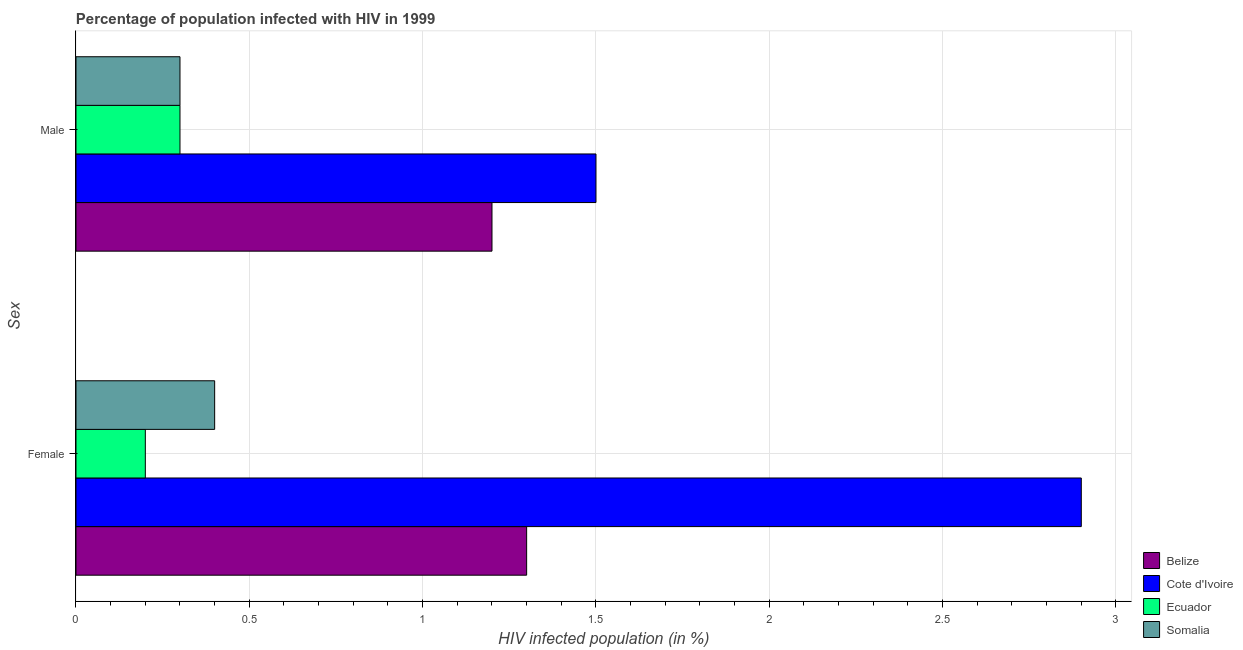How many different coloured bars are there?
Offer a very short reply. 4. How many groups of bars are there?
Your answer should be compact. 2. Are the number of bars per tick equal to the number of legend labels?
Your answer should be compact. Yes. Are the number of bars on each tick of the Y-axis equal?
Your answer should be very brief. Yes. How many bars are there on the 2nd tick from the bottom?
Make the answer very short. 4. Across all countries, what is the maximum percentage of males who are infected with hiv?
Provide a short and direct response. 1.5. Across all countries, what is the minimum percentage of males who are infected with hiv?
Provide a short and direct response. 0.3. In which country was the percentage of males who are infected with hiv maximum?
Make the answer very short. Cote d'Ivoire. In which country was the percentage of females who are infected with hiv minimum?
Your answer should be compact. Ecuador. What is the total percentage of females who are infected with hiv in the graph?
Your answer should be compact. 4.8. What is the difference between the percentage of males who are infected with hiv in Cote d'Ivoire and that in Belize?
Offer a very short reply. 0.3. What is the difference between the percentage of females who are infected with hiv in Belize and the percentage of males who are infected with hiv in Cote d'Ivoire?
Ensure brevity in your answer.  -0.2. What is the average percentage of females who are infected with hiv per country?
Your answer should be compact. 1.2. What is the difference between the percentage of females who are infected with hiv and percentage of males who are infected with hiv in Belize?
Provide a succinct answer. 0.1. In how many countries, is the percentage of females who are infected with hiv greater than 1 %?
Offer a terse response. 2. What is the ratio of the percentage of males who are infected with hiv in Belize to that in Cote d'Ivoire?
Provide a succinct answer. 0.8. Is the percentage of males who are infected with hiv in Belize less than that in Somalia?
Offer a very short reply. No. What does the 3rd bar from the top in Male represents?
Provide a succinct answer. Cote d'Ivoire. What does the 1st bar from the bottom in Female represents?
Your answer should be very brief. Belize. How many bars are there?
Keep it short and to the point. 8. Are all the bars in the graph horizontal?
Your answer should be compact. Yes. What is the difference between two consecutive major ticks on the X-axis?
Provide a succinct answer. 0.5. Does the graph contain any zero values?
Provide a short and direct response. No. Does the graph contain grids?
Provide a short and direct response. Yes. How many legend labels are there?
Offer a very short reply. 4. What is the title of the graph?
Your answer should be very brief. Percentage of population infected with HIV in 1999. What is the label or title of the X-axis?
Make the answer very short. HIV infected population (in %). What is the label or title of the Y-axis?
Your answer should be compact. Sex. What is the HIV infected population (in %) in Belize in Female?
Ensure brevity in your answer.  1.3. What is the HIV infected population (in %) of Cote d'Ivoire in Female?
Offer a very short reply. 2.9. What is the HIV infected population (in %) in Somalia in Female?
Ensure brevity in your answer.  0.4. What is the HIV infected population (in %) of Cote d'Ivoire in Male?
Offer a very short reply. 1.5. What is the HIV infected population (in %) of Somalia in Male?
Your answer should be very brief. 0.3. Across all Sex, what is the maximum HIV infected population (in %) in Belize?
Offer a terse response. 1.3. Across all Sex, what is the maximum HIV infected population (in %) of Cote d'Ivoire?
Provide a succinct answer. 2.9. Across all Sex, what is the minimum HIV infected population (in %) of Ecuador?
Keep it short and to the point. 0.2. What is the total HIV infected population (in %) in Belize in the graph?
Make the answer very short. 2.5. What is the total HIV infected population (in %) of Cote d'Ivoire in the graph?
Make the answer very short. 4.4. What is the total HIV infected population (in %) of Ecuador in the graph?
Your answer should be compact. 0.5. What is the total HIV infected population (in %) in Somalia in the graph?
Your answer should be very brief. 0.7. What is the difference between the HIV infected population (in %) of Belize in Female and that in Male?
Make the answer very short. 0.1. What is the difference between the HIV infected population (in %) of Cote d'Ivoire in Female and that in Male?
Your answer should be very brief. 1.4. What is the difference between the HIV infected population (in %) in Ecuador in Female and that in Male?
Your answer should be compact. -0.1. What is the difference between the HIV infected population (in %) of Somalia in Female and that in Male?
Your response must be concise. 0.1. What is the average HIV infected population (in %) of Belize per Sex?
Your response must be concise. 1.25. What is the average HIV infected population (in %) in Cote d'Ivoire per Sex?
Make the answer very short. 2.2. What is the average HIV infected population (in %) of Ecuador per Sex?
Ensure brevity in your answer.  0.25. What is the difference between the HIV infected population (in %) of Belize and HIV infected population (in %) of Cote d'Ivoire in Female?
Ensure brevity in your answer.  -1.6. What is the difference between the HIV infected population (in %) of Belize and HIV infected population (in %) of Somalia in Female?
Offer a very short reply. 0.9. What is the difference between the HIV infected population (in %) of Cote d'Ivoire and HIV infected population (in %) of Ecuador in Female?
Make the answer very short. 2.7. What is the difference between the HIV infected population (in %) in Cote d'Ivoire and HIV infected population (in %) in Somalia in Female?
Make the answer very short. 2.5. What is the difference between the HIV infected population (in %) of Belize and HIV infected population (in %) of Somalia in Male?
Offer a terse response. 0.9. What is the difference between the HIV infected population (in %) in Cote d'Ivoire and HIV infected population (in %) in Ecuador in Male?
Provide a short and direct response. 1.2. What is the difference between the HIV infected population (in %) of Ecuador and HIV infected population (in %) of Somalia in Male?
Provide a short and direct response. 0. What is the ratio of the HIV infected population (in %) of Belize in Female to that in Male?
Offer a very short reply. 1.08. What is the ratio of the HIV infected population (in %) in Cote d'Ivoire in Female to that in Male?
Provide a short and direct response. 1.93. What is the ratio of the HIV infected population (in %) of Somalia in Female to that in Male?
Offer a terse response. 1.33. What is the difference between the highest and the second highest HIV infected population (in %) of Cote d'Ivoire?
Make the answer very short. 1.4. What is the difference between the highest and the second highest HIV infected population (in %) in Ecuador?
Offer a very short reply. 0.1. What is the difference between the highest and the lowest HIV infected population (in %) of Belize?
Make the answer very short. 0.1. What is the difference between the highest and the lowest HIV infected population (in %) of Ecuador?
Give a very brief answer. 0.1. What is the difference between the highest and the lowest HIV infected population (in %) in Somalia?
Give a very brief answer. 0.1. 